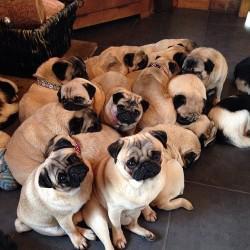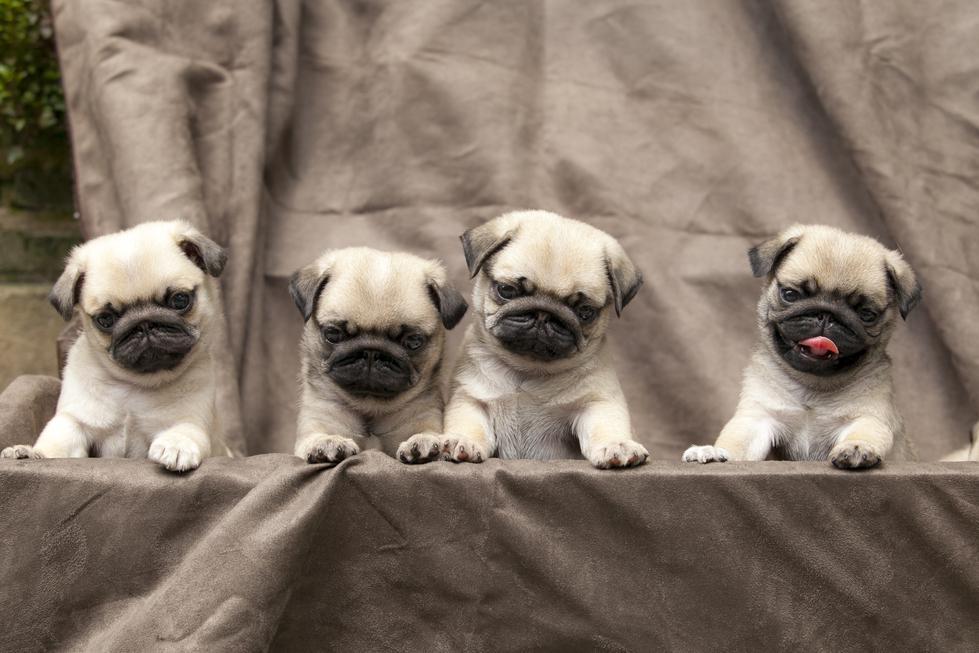The first image is the image on the left, the second image is the image on the right. Examine the images to the left and right. Is the description "The left image features one forward-facing black pug with front paws draped over something, and the right image features a black pug to the left of a beige pug." accurate? Answer yes or no. No. The first image is the image on the left, the second image is the image on the right. Analyze the images presented: Is the assertion "The right image contains exactly two dogs." valid? Answer yes or no. No. 